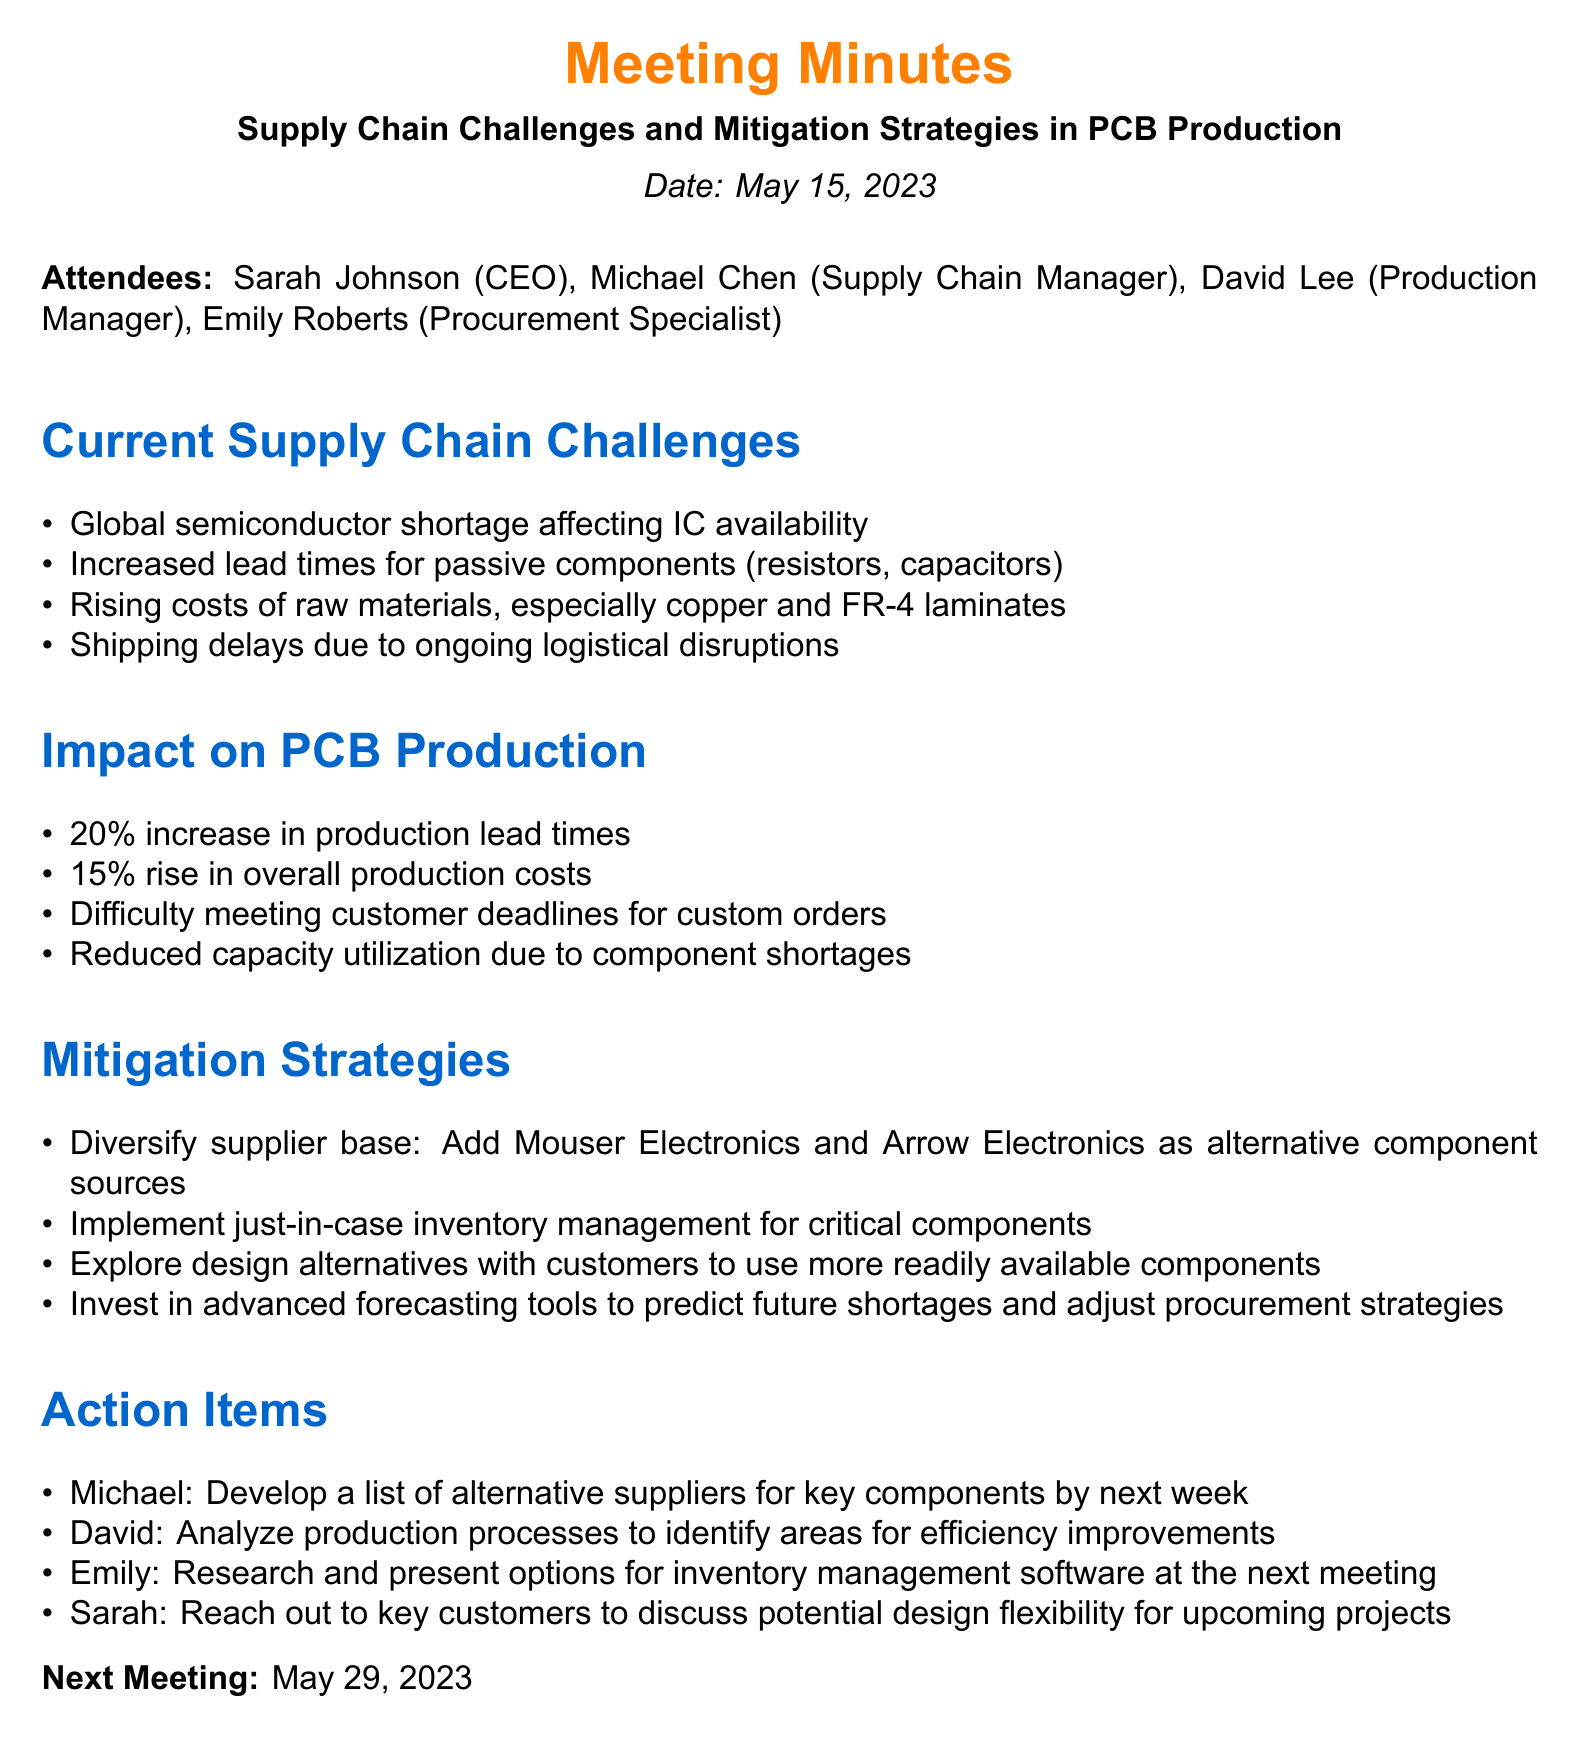What is the date of the meeting? The meeting took place on May 15, 2023.
Answer: May 15, 2023 Who is the Procurement Specialist? The document lists Emily Roberts as the Procurement Specialist.
Answer: Emily Roberts What is one of the current supply chain challenges? The document mentions a global semiconductor shortage affecting IC availability as a challenge.
Answer: Global semiconductor shortage What percentage increase in production lead times is mentioned? The document states a 20% increase in production lead times.
Answer: 20% What action is assigned to Michael? Michael is tasked with developing a list of alternative suppliers for key components by next week.
Answer: Develop a list of alternative suppliers What strategy involves adding Mouser Electronics and Arrow Electronics? This refers to diversifying the supplier base to mitigate component shortages.
Answer: Diversify supplier base What is the next meeting date? The next meeting is scheduled for May 29, 2023.
Answer: May 29, 2023 What is the percentage rise in overall production costs? The document indicates a 15% rise in overall production costs.
Answer: 15% What is an objective for Emily before the next meeting? Emily is to research and present options for inventory management software at the next meeting.
Answer: Research options for inventory management software 